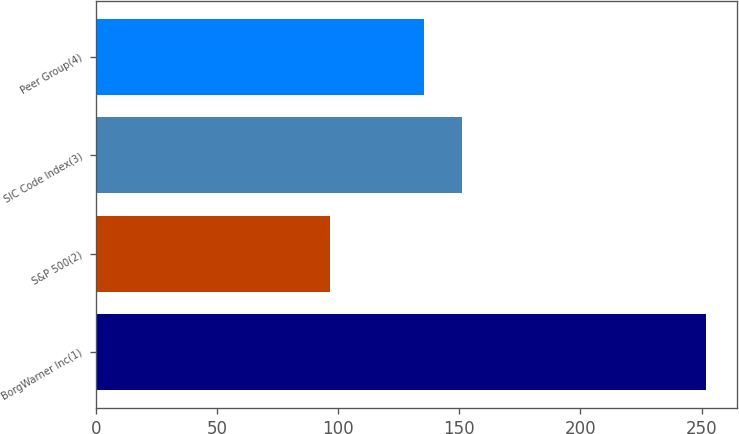Convert chart to OTSL. <chart><loc_0><loc_0><loc_500><loc_500><bar_chart><fcel>BorgWarner Inc(1)<fcel>S&P 500(2)<fcel>SIC Code Index(3)<fcel>Peer Group(4)<nl><fcel>252.01<fcel>96.71<fcel>151.06<fcel>135.53<nl></chart> 